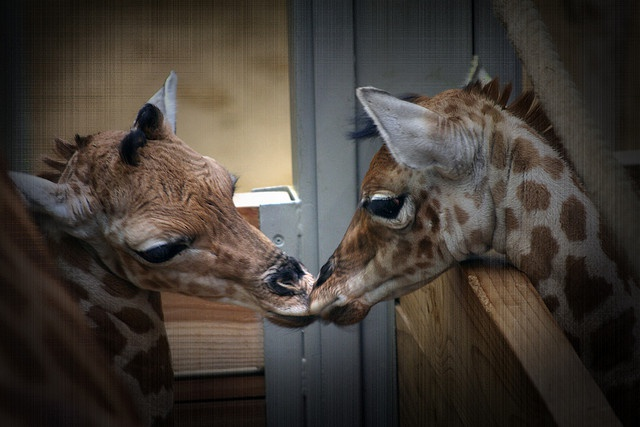Describe the objects in this image and their specific colors. I can see giraffe in black, gray, and maroon tones and giraffe in black and gray tones in this image. 